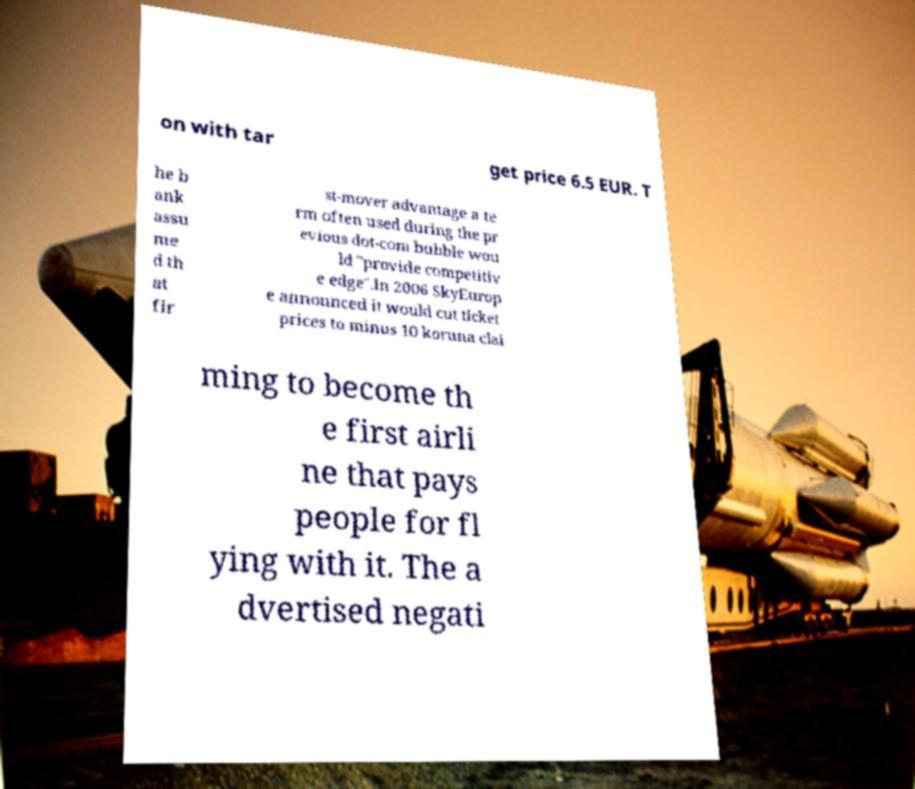Please read and relay the text visible in this image. What does it say? on with tar get price 6.5 EUR. T he b ank assu me d th at fir st-mover advantage a te rm often used during the pr evious dot-com bubble wou ld "provide competitiv e edge".In 2006 SkyEurop e announced it would cut ticket prices to minus 10 koruna clai ming to become th e first airli ne that pays people for fl ying with it. The a dvertised negati 